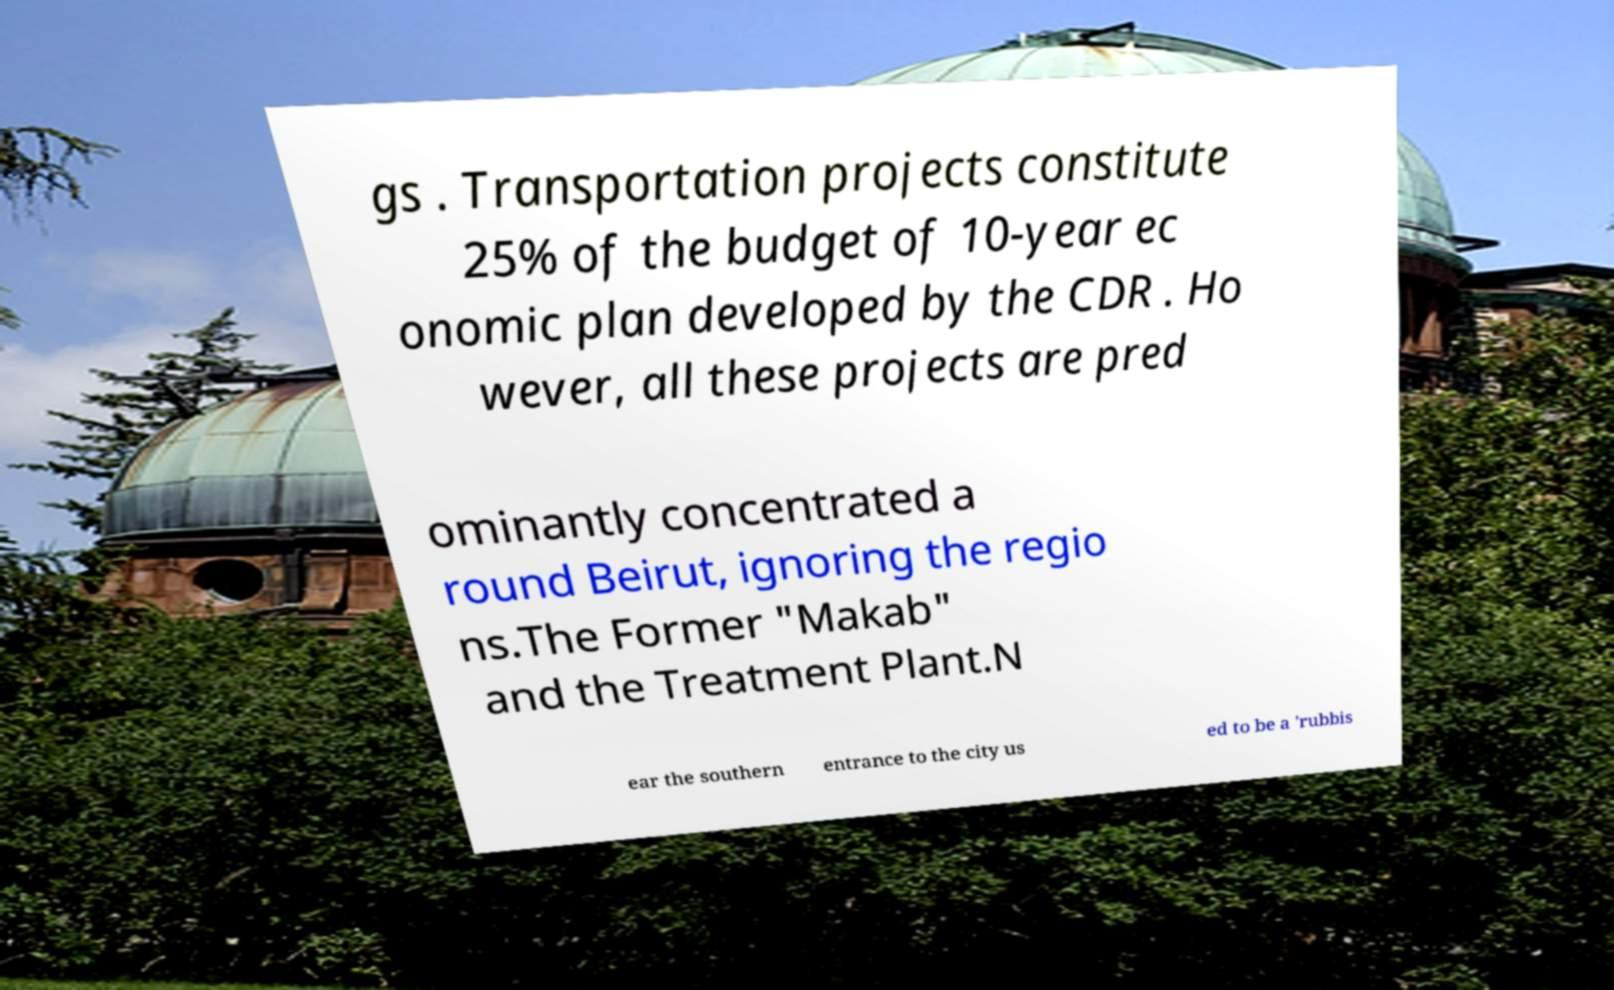Can you accurately transcribe the text from the provided image for me? gs . Transportation projects constitute 25% of the budget of 10-year ec onomic plan developed by the CDR . Ho wever, all these projects are pred ominantly concentrated a round Beirut, ignoring the regio ns.The Former "Makab" and the Treatment Plant.N ear the southern entrance to the city us ed to be a 'rubbis 